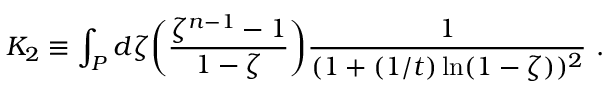<formula> <loc_0><loc_0><loc_500><loc_500>K _ { 2 } \equiv \int _ { P } d \zeta \left ( { \frac { \zeta ^ { n - 1 } - 1 } { 1 - \zeta } } \right ) { \frac { 1 } { ( 1 + ( 1 / t ) \ln ( 1 - \zeta ) ) ^ { 2 } } } \ .</formula> 